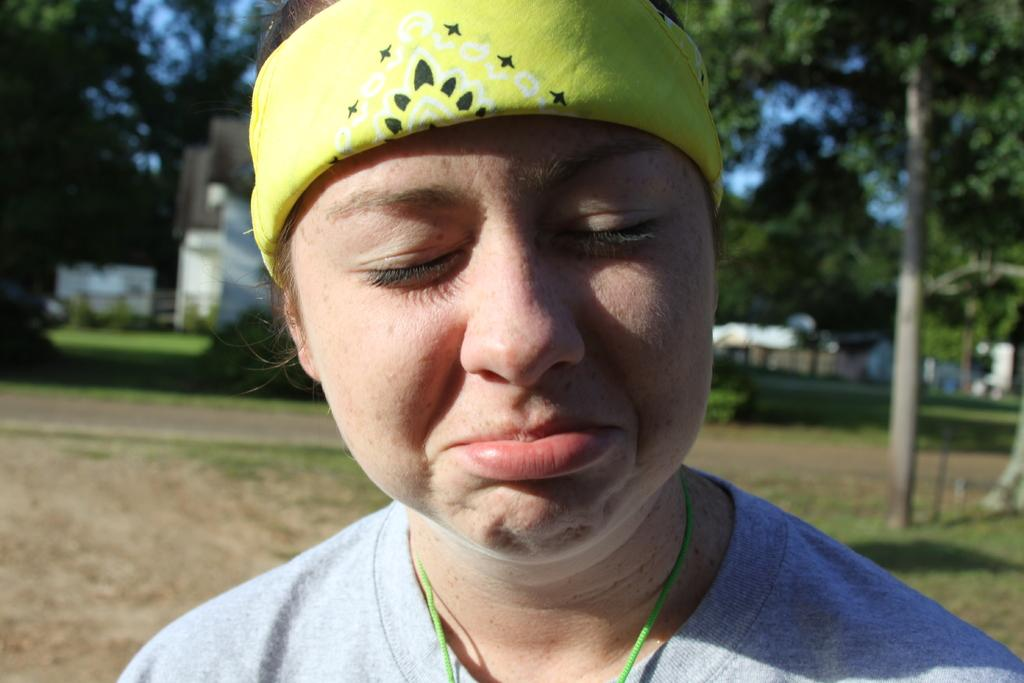Who is present in the image? There is a woman in the image. What can be seen in the background of the image? There are trees and the sky visible in the background of the image. How is the background of the image depicted? The background of the image is blurred. How many cows are causing trouble in the image? There are no cows present in the image, and therefore no trouble can be attributed to them. 